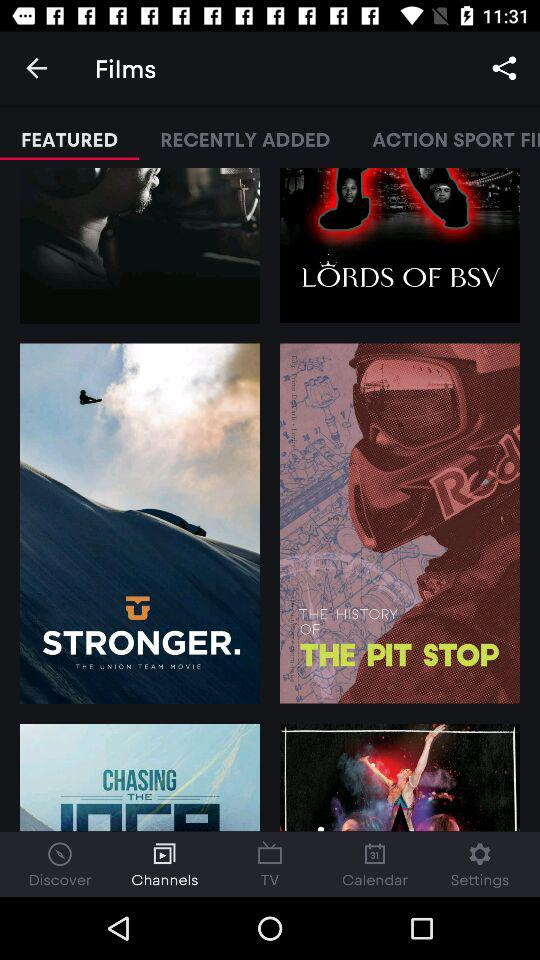Which tab has been selected? The selected tabs are "FEATURED" and "Channels". 